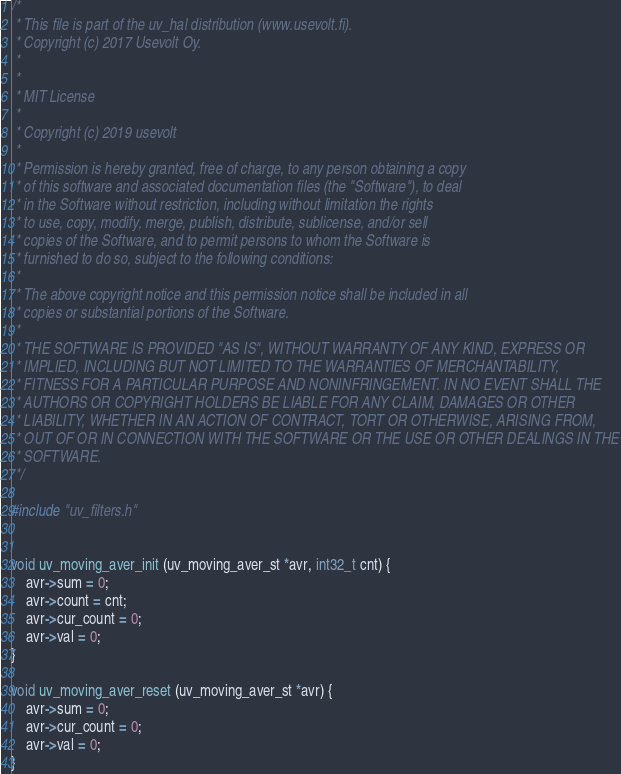<code> <loc_0><loc_0><loc_500><loc_500><_C_>/* 
 * This file is part of the uv_hal distribution (www.usevolt.fi).
 * Copyright (c) 2017 Usevolt Oy.
 * 
 *
 * MIT License
 *
 * Copyright (c) 2019 usevolt
 *
 * Permission is hereby granted, free of charge, to any person obtaining a copy
 * of this software and associated documentation files (the "Software"), to deal
 * in the Software without restriction, including without limitation the rights
 * to use, copy, modify, merge, publish, distribute, sublicense, and/or sell
 * copies of the Software, and to permit persons to whom the Software is
 * furnished to do so, subject to the following conditions:
 *
 * The above copyright notice and this permission notice shall be included in all
 * copies or substantial portions of the Software.
 *
 * THE SOFTWARE IS PROVIDED "AS IS", WITHOUT WARRANTY OF ANY KIND, EXPRESS OR
 * IMPLIED, INCLUDING BUT NOT LIMITED TO THE WARRANTIES OF MERCHANTABILITY,
 * FITNESS FOR A PARTICULAR PURPOSE AND NONINFRINGEMENT. IN NO EVENT SHALL THE
 * AUTHORS OR COPYRIGHT HOLDERS BE LIABLE FOR ANY CLAIM, DAMAGES OR OTHER
 * LIABILITY, WHETHER IN AN ACTION OF CONTRACT, TORT OR OTHERWISE, ARISING FROM,
 * OUT OF OR IN CONNECTION WITH THE SOFTWARE OR THE USE OR OTHER DEALINGS IN THE
 * SOFTWARE.
 */

#include "uv_filters.h"


void uv_moving_aver_init (uv_moving_aver_st *avr, int32_t cnt) {
	avr->sum = 0;
	avr->count = cnt;
	avr->cur_count = 0;
	avr->val = 0;
}

void uv_moving_aver_reset (uv_moving_aver_st *avr) {
	avr->sum = 0;
	avr->cur_count = 0;
	avr->val = 0;
}
</code> 